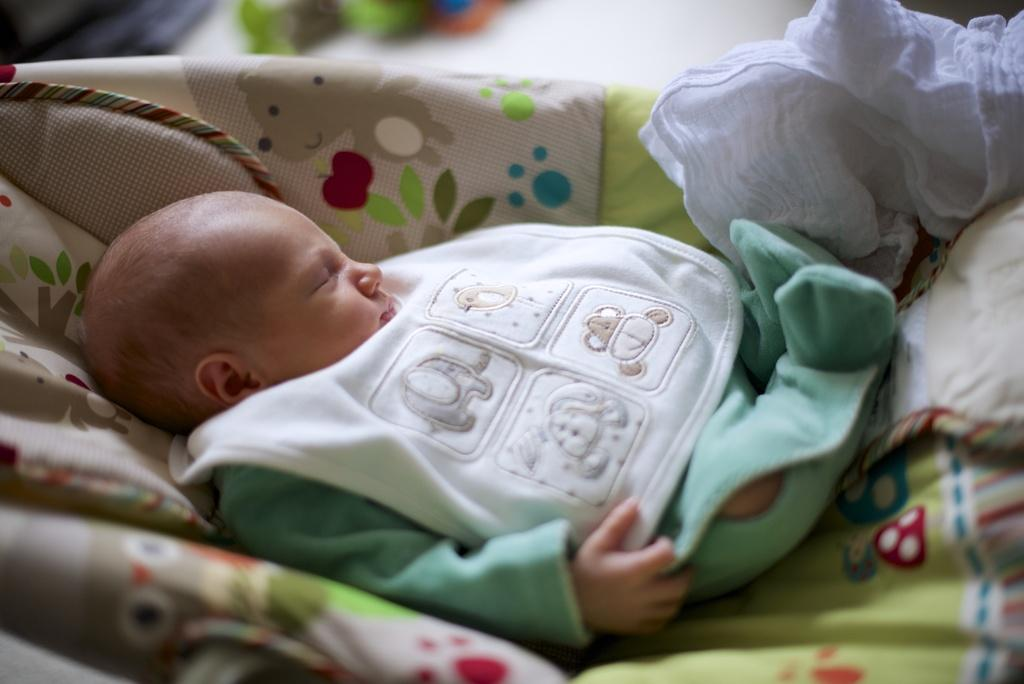What type of cloth is featured in the image? There is a colorful cloth in the image. What is placed on the colorful cloth? A baby is present on the colorful cloth. What is the baby wearing? The baby is wearing a green dress. What other type of cloth is visible in the image? There is a white cloth in the image. What is depicted on the white cloth? Cartoons are visible on the white cloth. How many zebras can be seen walking through the door in the image? There are no zebras or doors present in the image. What type of planes are visible in the image? There are no planes present in the image. 